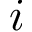Convert formula to latex. <formula><loc_0><loc_0><loc_500><loc_500>i</formula> 